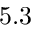<formula> <loc_0><loc_0><loc_500><loc_500>5 . 3</formula> 